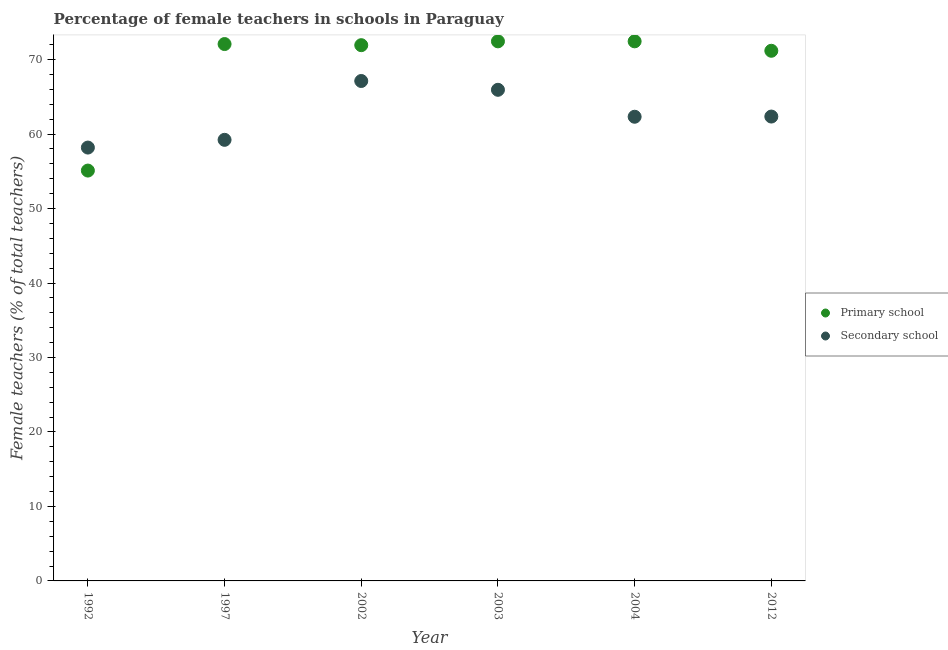How many different coloured dotlines are there?
Offer a very short reply. 2. Is the number of dotlines equal to the number of legend labels?
Keep it short and to the point. Yes. What is the percentage of female teachers in primary schools in 2002?
Your response must be concise. 71.93. Across all years, what is the maximum percentage of female teachers in secondary schools?
Give a very brief answer. 67.12. Across all years, what is the minimum percentage of female teachers in primary schools?
Offer a very short reply. 55.1. In which year was the percentage of female teachers in primary schools maximum?
Your response must be concise. 2004. What is the total percentage of female teachers in secondary schools in the graph?
Give a very brief answer. 375.14. What is the difference between the percentage of female teachers in secondary schools in 1992 and that in 2002?
Offer a terse response. -8.94. What is the difference between the percentage of female teachers in secondary schools in 2002 and the percentage of female teachers in primary schools in 2004?
Keep it short and to the point. -5.32. What is the average percentage of female teachers in secondary schools per year?
Your answer should be very brief. 62.52. In the year 2002, what is the difference between the percentage of female teachers in secondary schools and percentage of female teachers in primary schools?
Your answer should be very brief. -4.81. What is the ratio of the percentage of female teachers in primary schools in 1997 to that in 2004?
Make the answer very short. 0.99. Is the percentage of female teachers in primary schools in 2003 less than that in 2004?
Give a very brief answer. Yes. What is the difference between the highest and the second highest percentage of female teachers in secondary schools?
Give a very brief answer. 1.18. What is the difference between the highest and the lowest percentage of female teachers in primary schools?
Offer a very short reply. 17.35. Is the sum of the percentage of female teachers in primary schools in 1992 and 2002 greater than the maximum percentage of female teachers in secondary schools across all years?
Make the answer very short. Yes. Is the percentage of female teachers in primary schools strictly greater than the percentage of female teachers in secondary schools over the years?
Your response must be concise. No. How many dotlines are there?
Your response must be concise. 2. What is the difference between two consecutive major ticks on the Y-axis?
Your answer should be compact. 10. How many legend labels are there?
Your answer should be compact. 2. How are the legend labels stacked?
Provide a short and direct response. Vertical. What is the title of the graph?
Make the answer very short. Percentage of female teachers in schools in Paraguay. Does "Urban agglomerations" appear as one of the legend labels in the graph?
Give a very brief answer. No. What is the label or title of the Y-axis?
Your answer should be very brief. Female teachers (% of total teachers). What is the Female teachers (% of total teachers) of Primary school in 1992?
Offer a terse response. 55.1. What is the Female teachers (% of total teachers) in Secondary school in 1992?
Your answer should be compact. 58.18. What is the Female teachers (% of total teachers) in Primary school in 1997?
Offer a terse response. 72.08. What is the Female teachers (% of total teachers) in Secondary school in 1997?
Provide a short and direct response. 59.22. What is the Female teachers (% of total teachers) in Primary school in 2002?
Your response must be concise. 71.93. What is the Female teachers (% of total teachers) of Secondary school in 2002?
Provide a short and direct response. 67.12. What is the Female teachers (% of total teachers) of Primary school in 2003?
Your answer should be compact. 72.45. What is the Female teachers (% of total teachers) of Secondary school in 2003?
Your answer should be very brief. 65.94. What is the Female teachers (% of total teachers) of Primary school in 2004?
Provide a short and direct response. 72.45. What is the Female teachers (% of total teachers) of Secondary school in 2004?
Offer a very short reply. 62.32. What is the Female teachers (% of total teachers) in Primary school in 2012?
Offer a terse response. 71.18. What is the Female teachers (% of total teachers) in Secondary school in 2012?
Your answer should be very brief. 62.35. Across all years, what is the maximum Female teachers (% of total teachers) of Primary school?
Offer a very short reply. 72.45. Across all years, what is the maximum Female teachers (% of total teachers) in Secondary school?
Your answer should be compact. 67.12. Across all years, what is the minimum Female teachers (% of total teachers) of Primary school?
Give a very brief answer. 55.1. Across all years, what is the minimum Female teachers (% of total teachers) in Secondary school?
Make the answer very short. 58.18. What is the total Female teachers (% of total teachers) of Primary school in the graph?
Your answer should be very brief. 415.18. What is the total Female teachers (% of total teachers) in Secondary school in the graph?
Your answer should be compact. 375.14. What is the difference between the Female teachers (% of total teachers) in Primary school in 1992 and that in 1997?
Your answer should be very brief. -16.99. What is the difference between the Female teachers (% of total teachers) of Secondary school in 1992 and that in 1997?
Provide a succinct answer. -1.04. What is the difference between the Female teachers (% of total teachers) of Primary school in 1992 and that in 2002?
Ensure brevity in your answer.  -16.84. What is the difference between the Female teachers (% of total teachers) of Secondary school in 1992 and that in 2002?
Your answer should be compact. -8.94. What is the difference between the Female teachers (% of total teachers) of Primary school in 1992 and that in 2003?
Your answer should be very brief. -17.35. What is the difference between the Female teachers (% of total teachers) of Secondary school in 1992 and that in 2003?
Give a very brief answer. -7.76. What is the difference between the Female teachers (% of total teachers) of Primary school in 1992 and that in 2004?
Make the answer very short. -17.35. What is the difference between the Female teachers (% of total teachers) of Secondary school in 1992 and that in 2004?
Your answer should be very brief. -4.14. What is the difference between the Female teachers (% of total teachers) of Primary school in 1992 and that in 2012?
Offer a very short reply. -16.08. What is the difference between the Female teachers (% of total teachers) in Secondary school in 1992 and that in 2012?
Ensure brevity in your answer.  -4.16. What is the difference between the Female teachers (% of total teachers) in Primary school in 1997 and that in 2002?
Give a very brief answer. 0.15. What is the difference between the Female teachers (% of total teachers) in Secondary school in 1997 and that in 2002?
Ensure brevity in your answer.  -7.9. What is the difference between the Female teachers (% of total teachers) in Primary school in 1997 and that in 2003?
Ensure brevity in your answer.  -0.36. What is the difference between the Female teachers (% of total teachers) of Secondary school in 1997 and that in 2003?
Your answer should be very brief. -6.72. What is the difference between the Female teachers (% of total teachers) of Primary school in 1997 and that in 2004?
Your answer should be very brief. -0.36. What is the difference between the Female teachers (% of total teachers) of Secondary school in 1997 and that in 2004?
Make the answer very short. -3.1. What is the difference between the Female teachers (% of total teachers) of Primary school in 1997 and that in 2012?
Give a very brief answer. 0.9. What is the difference between the Female teachers (% of total teachers) of Secondary school in 1997 and that in 2012?
Offer a terse response. -3.13. What is the difference between the Female teachers (% of total teachers) in Primary school in 2002 and that in 2003?
Your response must be concise. -0.51. What is the difference between the Female teachers (% of total teachers) of Secondary school in 2002 and that in 2003?
Offer a terse response. 1.18. What is the difference between the Female teachers (% of total teachers) of Primary school in 2002 and that in 2004?
Provide a succinct answer. -0.52. What is the difference between the Female teachers (% of total teachers) in Secondary school in 2002 and that in 2004?
Offer a very short reply. 4.8. What is the difference between the Female teachers (% of total teachers) of Primary school in 2002 and that in 2012?
Your answer should be compact. 0.75. What is the difference between the Female teachers (% of total teachers) in Secondary school in 2002 and that in 2012?
Ensure brevity in your answer.  4.77. What is the difference between the Female teachers (% of total teachers) in Primary school in 2003 and that in 2004?
Your response must be concise. -0. What is the difference between the Female teachers (% of total teachers) in Secondary school in 2003 and that in 2004?
Your answer should be compact. 3.62. What is the difference between the Female teachers (% of total teachers) of Primary school in 2003 and that in 2012?
Your answer should be compact. 1.27. What is the difference between the Female teachers (% of total teachers) in Secondary school in 2003 and that in 2012?
Provide a short and direct response. 3.59. What is the difference between the Female teachers (% of total teachers) in Primary school in 2004 and that in 2012?
Keep it short and to the point. 1.27. What is the difference between the Female teachers (% of total teachers) in Secondary school in 2004 and that in 2012?
Offer a very short reply. -0.03. What is the difference between the Female teachers (% of total teachers) of Primary school in 1992 and the Female teachers (% of total teachers) of Secondary school in 1997?
Make the answer very short. -4.13. What is the difference between the Female teachers (% of total teachers) of Primary school in 1992 and the Female teachers (% of total teachers) of Secondary school in 2002?
Your answer should be compact. -12.03. What is the difference between the Female teachers (% of total teachers) of Primary school in 1992 and the Female teachers (% of total teachers) of Secondary school in 2003?
Provide a succinct answer. -10.84. What is the difference between the Female teachers (% of total teachers) of Primary school in 1992 and the Female teachers (% of total teachers) of Secondary school in 2004?
Your answer should be very brief. -7.23. What is the difference between the Female teachers (% of total teachers) of Primary school in 1992 and the Female teachers (% of total teachers) of Secondary school in 2012?
Make the answer very short. -7.25. What is the difference between the Female teachers (% of total teachers) in Primary school in 1997 and the Female teachers (% of total teachers) in Secondary school in 2002?
Make the answer very short. 4.96. What is the difference between the Female teachers (% of total teachers) in Primary school in 1997 and the Female teachers (% of total teachers) in Secondary school in 2003?
Offer a very short reply. 6.14. What is the difference between the Female teachers (% of total teachers) of Primary school in 1997 and the Female teachers (% of total teachers) of Secondary school in 2004?
Offer a terse response. 9.76. What is the difference between the Female teachers (% of total teachers) in Primary school in 1997 and the Female teachers (% of total teachers) in Secondary school in 2012?
Ensure brevity in your answer.  9.73. What is the difference between the Female teachers (% of total teachers) of Primary school in 2002 and the Female teachers (% of total teachers) of Secondary school in 2003?
Offer a terse response. 5.99. What is the difference between the Female teachers (% of total teachers) in Primary school in 2002 and the Female teachers (% of total teachers) in Secondary school in 2004?
Offer a very short reply. 9.61. What is the difference between the Female teachers (% of total teachers) in Primary school in 2002 and the Female teachers (% of total teachers) in Secondary school in 2012?
Give a very brief answer. 9.58. What is the difference between the Female teachers (% of total teachers) of Primary school in 2003 and the Female teachers (% of total teachers) of Secondary school in 2004?
Ensure brevity in your answer.  10.12. What is the difference between the Female teachers (% of total teachers) in Primary school in 2003 and the Female teachers (% of total teachers) in Secondary school in 2012?
Your answer should be compact. 10.1. What is the difference between the Female teachers (% of total teachers) of Primary school in 2004 and the Female teachers (% of total teachers) of Secondary school in 2012?
Offer a terse response. 10.1. What is the average Female teachers (% of total teachers) in Primary school per year?
Provide a short and direct response. 69.2. What is the average Female teachers (% of total teachers) in Secondary school per year?
Your answer should be compact. 62.52. In the year 1992, what is the difference between the Female teachers (% of total teachers) in Primary school and Female teachers (% of total teachers) in Secondary school?
Offer a terse response. -3.09. In the year 1997, what is the difference between the Female teachers (% of total teachers) in Primary school and Female teachers (% of total teachers) in Secondary school?
Provide a short and direct response. 12.86. In the year 2002, what is the difference between the Female teachers (% of total teachers) of Primary school and Female teachers (% of total teachers) of Secondary school?
Provide a succinct answer. 4.81. In the year 2003, what is the difference between the Female teachers (% of total teachers) in Primary school and Female teachers (% of total teachers) in Secondary school?
Provide a succinct answer. 6.51. In the year 2004, what is the difference between the Female teachers (% of total teachers) in Primary school and Female teachers (% of total teachers) in Secondary school?
Offer a very short reply. 10.13. In the year 2012, what is the difference between the Female teachers (% of total teachers) of Primary school and Female teachers (% of total teachers) of Secondary school?
Provide a succinct answer. 8.83. What is the ratio of the Female teachers (% of total teachers) in Primary school in 1992 to that in 1997?
Offer a terse response. 0.76. What is the ratio of the Female teachers (% of total teachers) of Secondary school in 1992 to that in 1997?
Make the answer very short. 0.98. What is the ratio of the Female teachers (% of total teachers) of Primary school in 1992 to that in 2002?
Provide a short and direct response. 0.77. What is the ratio of the Female teachers (% of total teachers) of Secondary school in 1992 to that in 2002?
Your answer should be very brief. 0.87. What is the ratio of the Female teachers (% of total teachers) of Primary school in 1992 to that in 2003?
Your answer should be compact. 0.76. What is the ratio of the Female teachers (% of total teachers) of Secondary school in 1992 to that in 2003?
Your answer should be compact. 0.88. What is the ratio of the Female teachers (% of total teachers) of Primary school in 1992 to that in 2004?
Provide a short and direct response. 0.76. What is the ratio of the Female teachers (% of total teachers) in Secondary school in 1992 to that in 2004?
Your response must be concise. 0.93. What is the ratio of the Female teachers (% of total teachers) of Primary school in 1992 to that in 2012?
Ensure brevity in your answer.  0.77. What is the ratio of the Female teachers (% of total teachers) of Secondary school in 1992 to that in 2012?
Give a very brief answer. 0.93. What is the ratio of the Female teachers (% of total teachers) of Primary school in 1997 to that in 2002?
Offer a very short reply. 1. What is the ratio of the Female teachers (% of total teachers) in Secondary school in 1997 to that in 2002?
Offer a terse response. 0.88. What is the ratio of the Female teachers (% of total teachers) of Secondary school in 1997 to that in 2003?
Provide a succinct answer. 0.9. What is the ratio of the Female teachers (% of total teachers) of Secondary school in 1997 to that in 2004?
Offer a terse response. 0.95. What is the ratio of the Female teachers (% of total teachers) in Primary school in 1997 to that in 2012?
Provide a succinct answer. 1.01. What is the ratio of the Female teachers (% of total teachers) of Secondary school in 1997 to that in 2012?
Your answer should be very brief. 0.95. What is the ratio of the Female teachers (% of total teachers) in Secondary school in 2002 to that in 2003?
Provide a succinct answer. 1.02. What is the ratio of the Female teachers (% of total teachers) of Primary school in 2002 to that in 2004?
Offer a very short reply. 0.99. What is the ratio of the Female teachers (% of total teachers) of Secondary school in 2002 to that in 2004?
Your answer should be very brief. 1.08. What is the ratio of the Female teachers (% of total teachers) of Primary school in 2002 to that in 2012?
Make the answer very short. 1.01. What is the ratio of the Female teachers (% of total teachers) of Secondary school in 2002 to that in 2012?
Offer a very short reply. 1.08. What is the ratio of the Female teachers (% of total teachers) of Secondary school in 2003 to that in 2004?
Provide a short and direct response. 1.06. What is the ratio of the Female teachers (% of total teachers) of Primary school in 2003 to that in 2012?
Make the answer very short. 1.02. What is the ratio of the Female teachers (% of total teachers) in Secondary school in 2003 to that in 2012?
Your response must be concise. 1.06. What is the ratio of the Female teachers (% of total teachers) of Primary school in 2004 to that in 2012?
Keep it short and to the point. 1.02. What is the ratio of the Female teachers (% of total teachers) of Secondary school in 2004 to that in 2012?
Your response must be concise. 1. What is the difference between the highest and the second highest Female teachers (% of total teachers) of Secondary school?
Provide a short and direct response. 1.18. What is the difference between the highest and the lowest Female teachers (% of total teachers) in Primary school?
Provide a short and direct response. 17.35. What is the difference between the highest and the lowest Female teachers (% of total teachers) of Secondary school?
Ensure brevity in your answer.  8.94. 